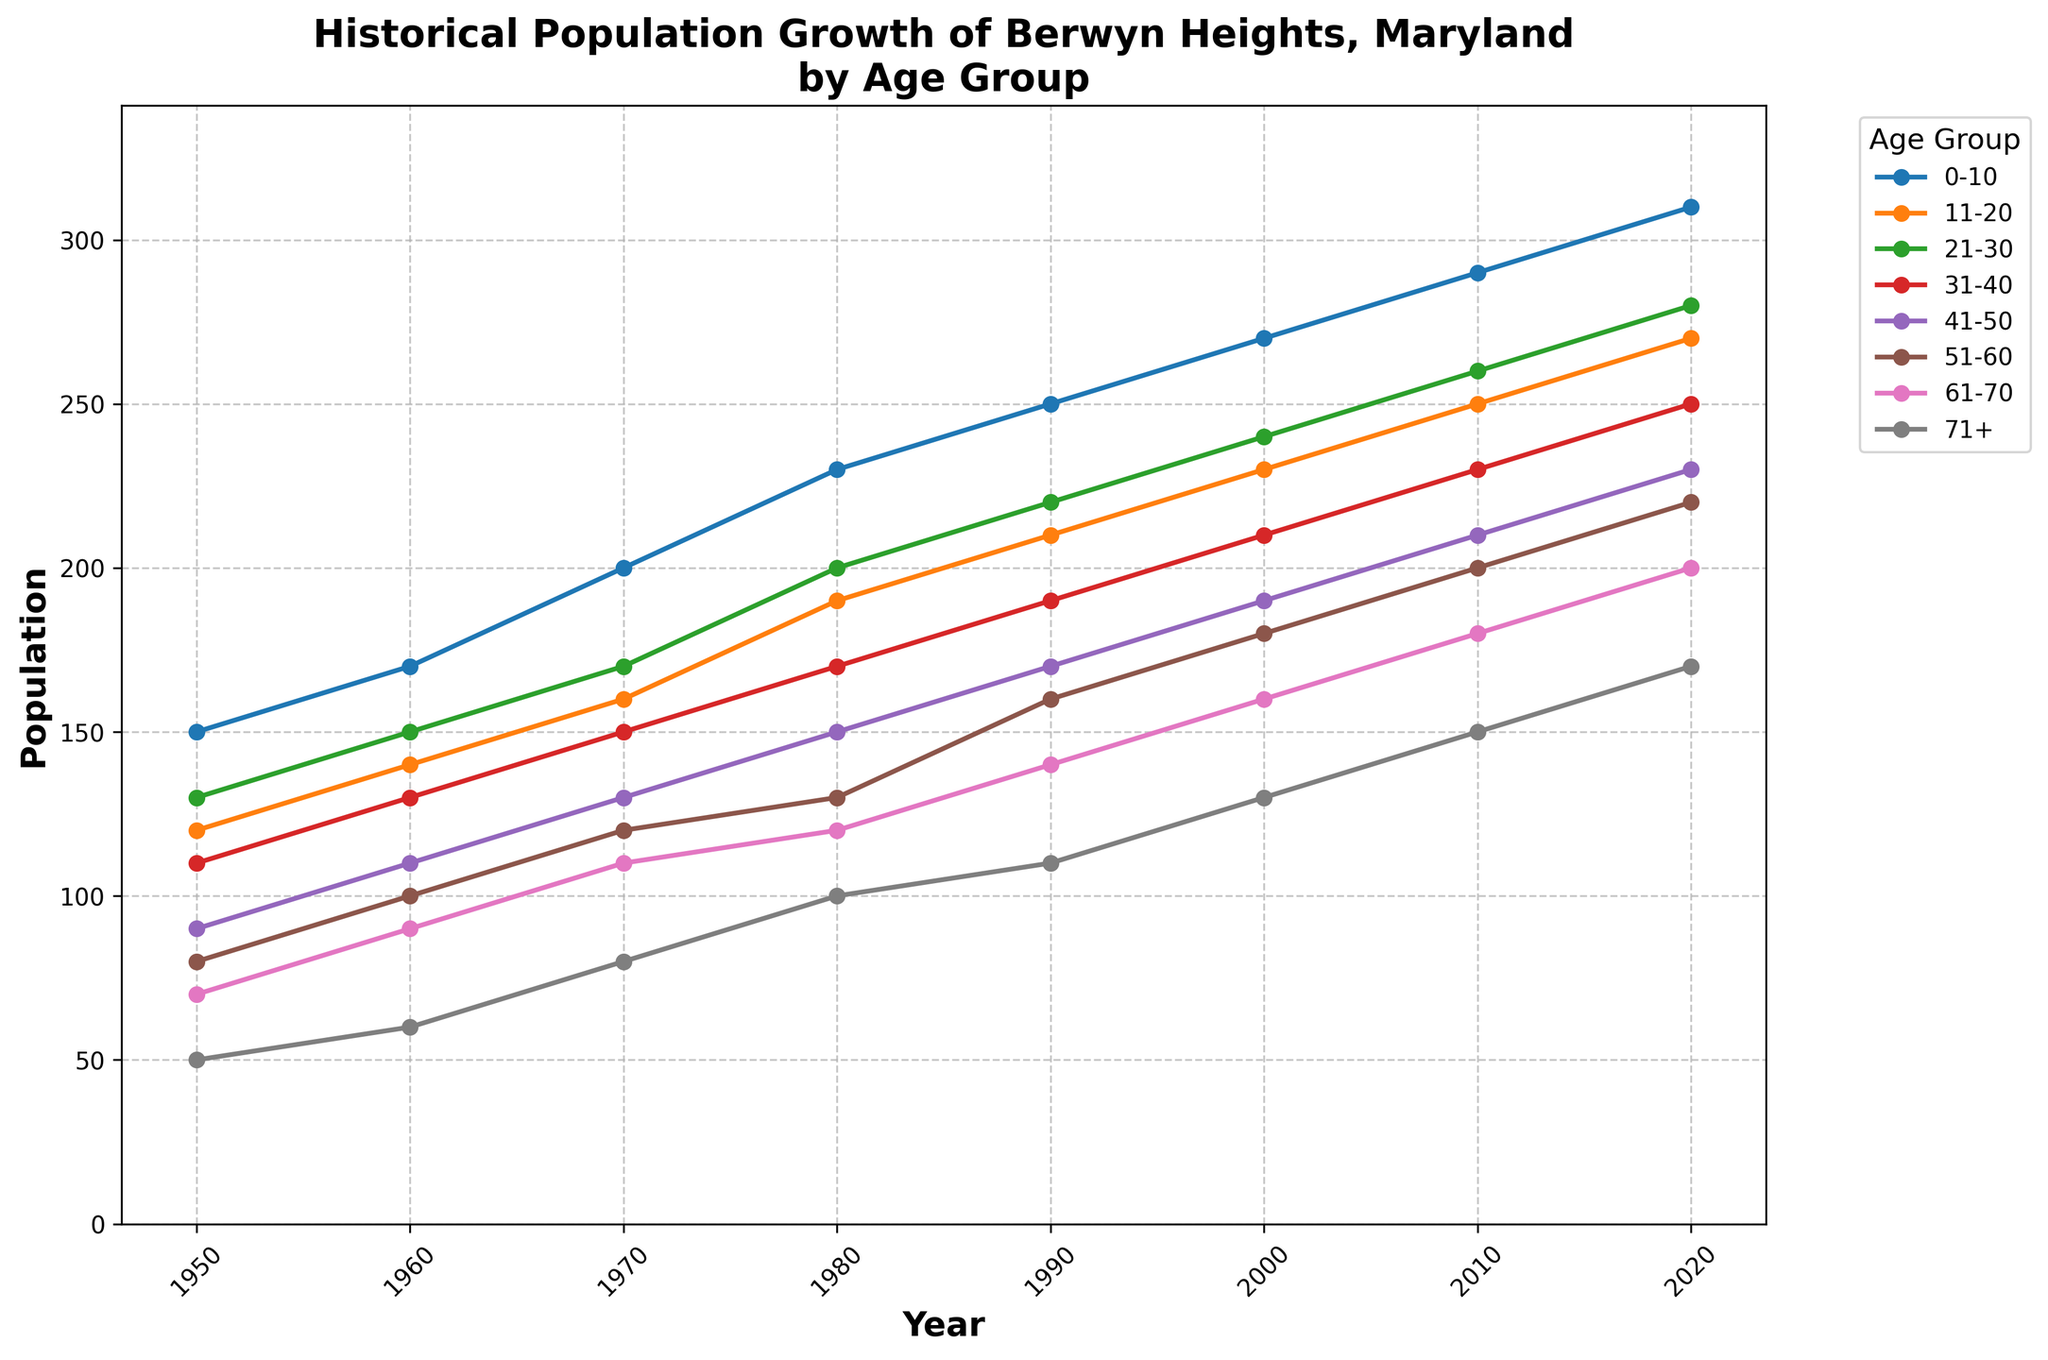What's the title of the plot? The title of a plot is usually found at the top of the figure. It helps to understand what the figure represents. In this case, the title is placed prominently at the top of the time series plot.
Answer: Historical Population Growth of Berwyn Heights, Maryland by Age Group What years are included on the x-axis? To find the years included on the x-axis, check the horizontal line at the bottom of the plot where the years are placed as tick marks. The range spans from the minimum to the maximum year provided in the dataset.
Answer: 1950 to 2020 Which age group had the lowest population in 1950? To determine the age group with the lowest population in 1950, locate the 1950 data points on the time series plot and identify the smallest value.
Answer: 71+ How has the population of the 21-30 age group changed from 1950 to 2020? To assess the change in population of the 21-30 age group over time, find the corresponding line for this age group on the plot and note the population values at the start (1950) and end (2020) years.
Answer: 130 to 280 Which age group showed the highest population increase between 2000 and 2020? Examine the data points for each age group at the years 2000 and 2020; calculate the differences, and compare to identify which group had the largest increase.
1. 0-10: 310 - 270 = 40
2. 11-20: 270 - 230 = 40
3. 21-30: 280 - 240 = 40
4. 31-40: 250 - 210 = 40
5. 41-50: 230 - 190 = 40
6. 51-60: 220 - 180 = 40
7. 61-70: 200 - 160 = 40
8. 71+: 170 - 130 = 40
All groups had an increase of 40
Answer: 0-10, 11-20, 21-30, 31-40, 41-50, 51-60, 61-70, 71+ During which decade did the 0-10 age group experience the highest population growth? Compare the population numbers provided for the 0-10 age group for each pair of consecutive decades and determine the decade with the highest difference:
1. 1950-1960: 170 - 150 = 20
2. 1960-1970: 200 - 170 = 30
3. 1970-1980: 230 - 200 = 30
4. 1980-1990: 250 - 230 = 20
5. 1990-2000: 270 - 250 = 20
6. 2000-2010: 290 - 270 = 20
7. 2010-2020: 310 - 290 = 20
The highest increase is 30, occurring during the 1960-1970 and 1970-1980 decades.
Answer: 1960-1970, 1970-1980 Which year had the peak population for the 71+ age group? To find the peak population year for the 71+ age group, locate the line corresponding to 71+ and find the highest point on the y-axis.
Answer: 2020 How does the population of the 31-40 age group in 1980 compare to that in 2010? Examine the data points for the 31-40 age group in 1980 and 2010, noting the values for each year on the y-axis.
1. Population in 1980: 170
2. Population in 2010: 230
Compare these values—2010 is higher.
Answer: 1980: 170, 2010: 230 What's the average population for the 51-60 age group over the entire time period? Calculate the average by summing the population for the 51-60 age group across all years and dividing by the number of years:
1. Sum: 80 + 100 + 120 + 130 + 160 + 180 + 200 + 220 = 1190
2. Number of years: 8
Average population = 1190 / 8
Answer: 148 Which age group appears to have the most consistent population growth? To identify the age group with the most consistent growth, observe the smoothness and slope of each line representing different age groups. The group that shows a steady, linear increase with minimal fluctuations would be the most consistent.
Answer: 0-10 